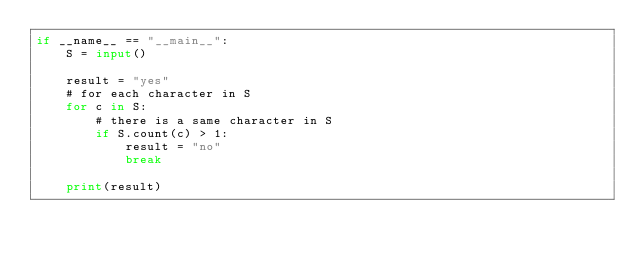Convert code to text. <code><loc_0><loc_0><loc_500><loc_500><_Python_>if __name__ == "__main__":
    S = input()

    result = "yes"
    # for each character in S
    for c in S:
        # there is a same character in S
        if S.count(c) > 1:
            result = "no"
            break

    print(result)</code> 